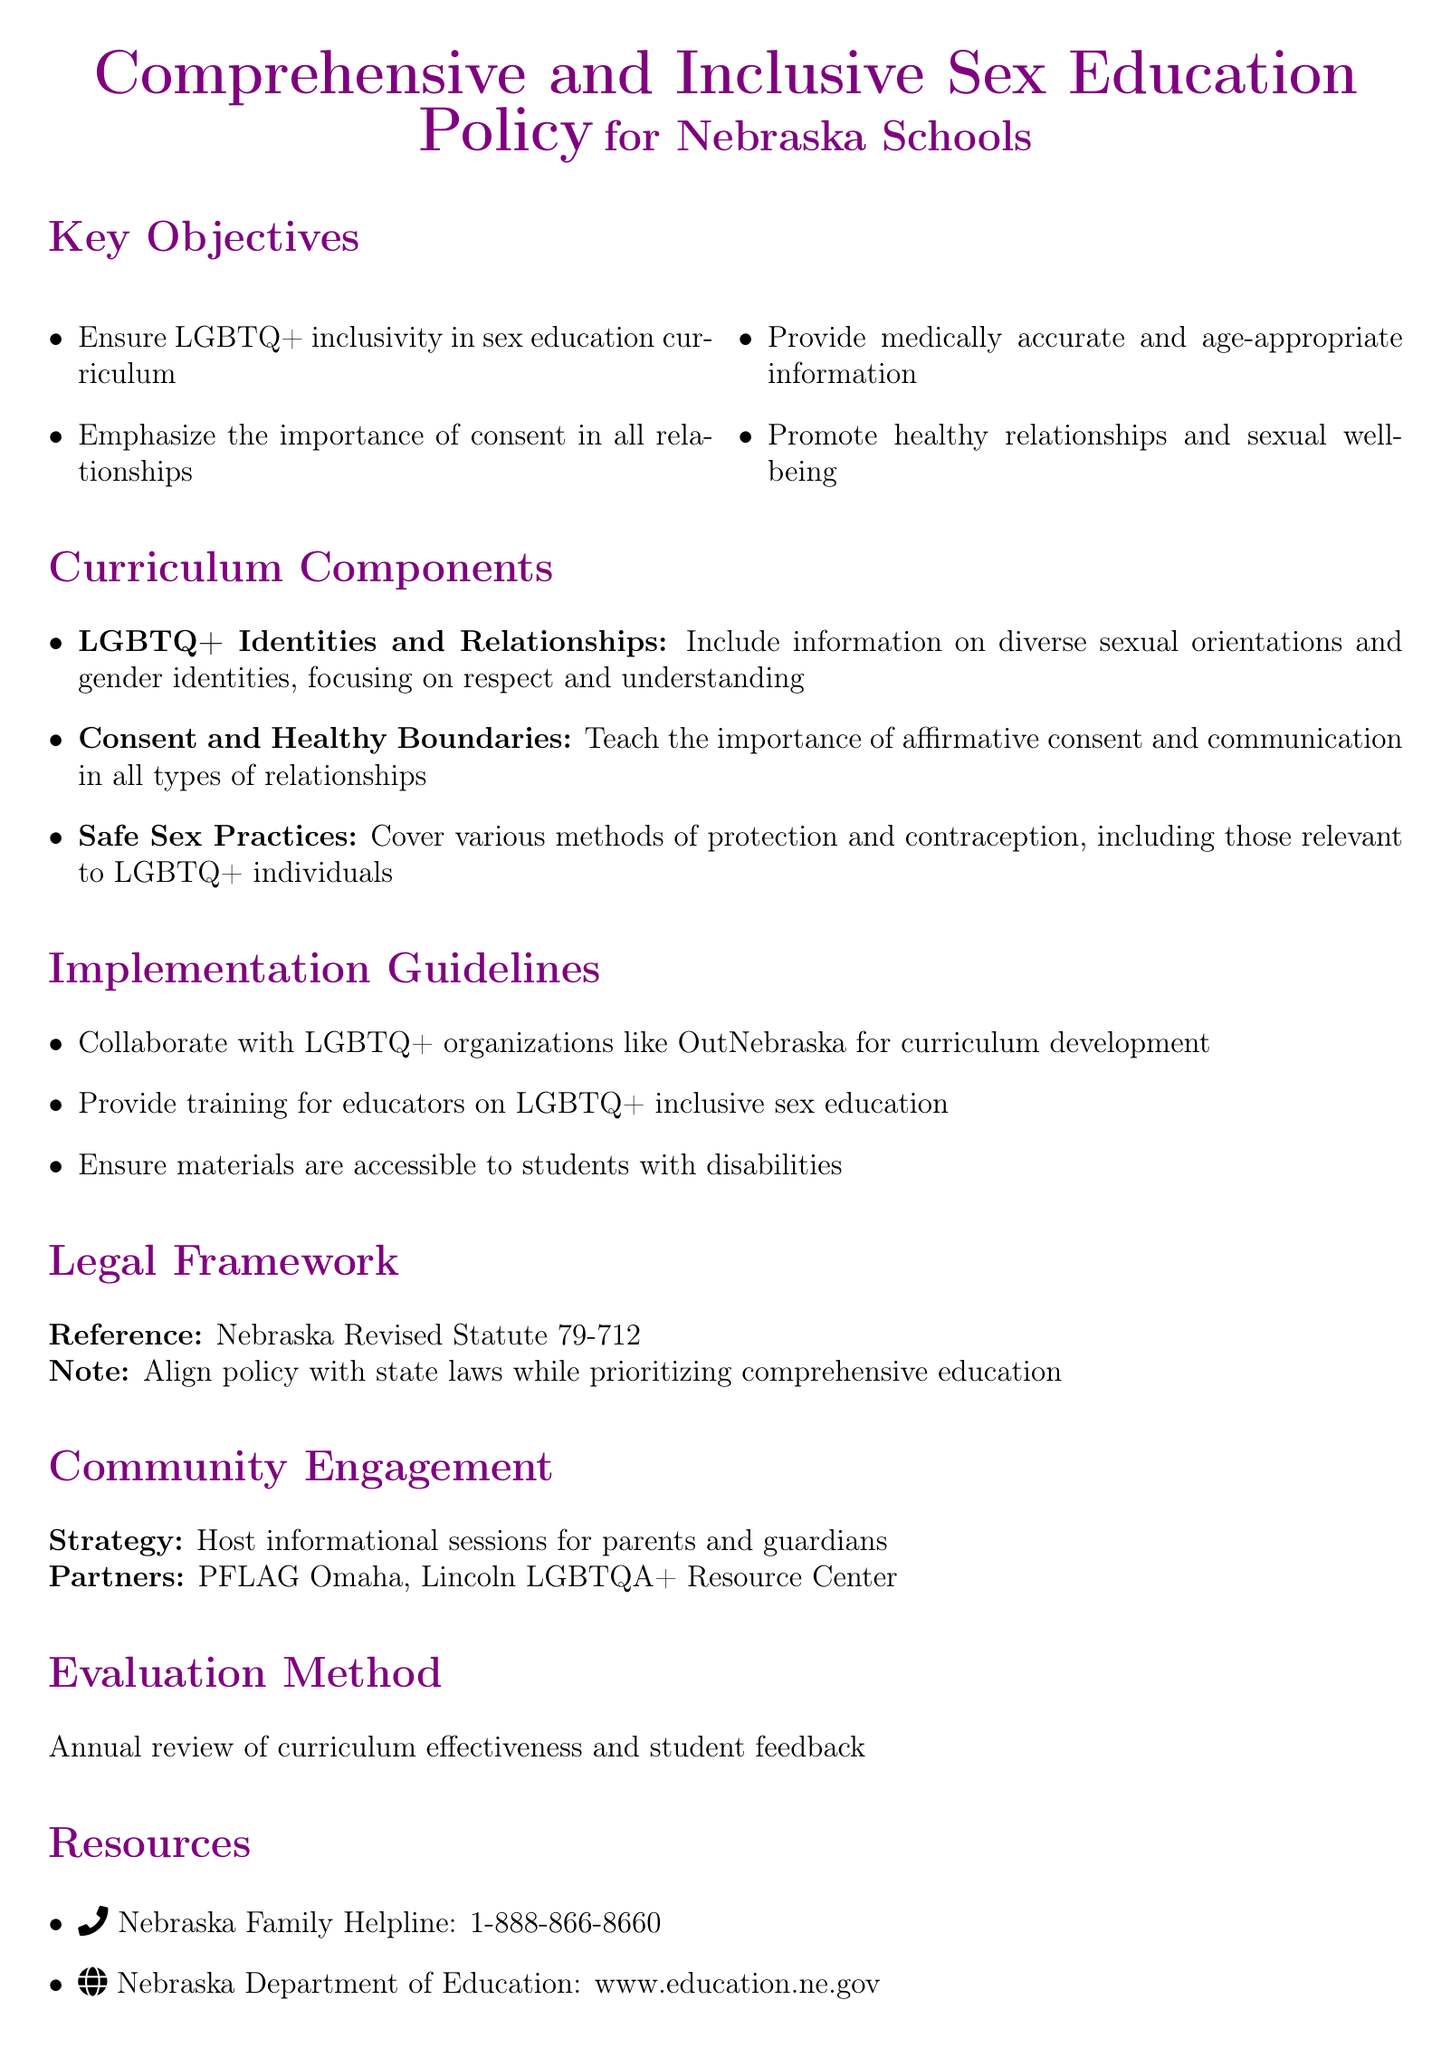What is the main focus of the policy? The main focus of the policy is to provide a comprehensive and inclusive sex education curriculum for Nebraska schools that ensures LGBTQ+ inclusivity and emphasizes consent.
Answer: Comprehensive and inclusive sex education What organization is mentioned for collaboration in curriculum development? The policy suggests collaboration with OutNebraska for curriculum development.
Answer: OutNebraska What is emphasized alongside LGBTQ+ inclusivity in the curriculum? The policy emphasizes the importance of consent in all relationships alongside LGBTQ+ inclusivity.
Answer: Consent What is the legal framework referenced in the document? The legal framework referenced is Nebraska Revised Statute 79-712.
Answer: Nebraska Revised Statute 79-712 Name one community partner mentioned for engagement. One community partner mentioned for engagement is PFLAG Omaha.
Answer: PFLAG Omaha What is the method of evaluating the curriculum effectiveness? The method of evaluating the curriculum effectiveness is through an annual review of curriculum effectiveness and student feedback.
Answer: Annual review How many key objectives are listed in the document? There are four key objectives listed in the document.
Answer: Four What type of training is suggested for educators? The policy suggests providing training for educators on LGBTQ+ inclusive sex education.
Answer: Training on LGBTQ+ inclusive sex education What does the curriculum component of safe sex practices include? The curriculum component of safe sex practices includes covering various methods of protection and contraception relevant to LGBTQ+ individuals.
Answer: Various methods of protection and contraception 